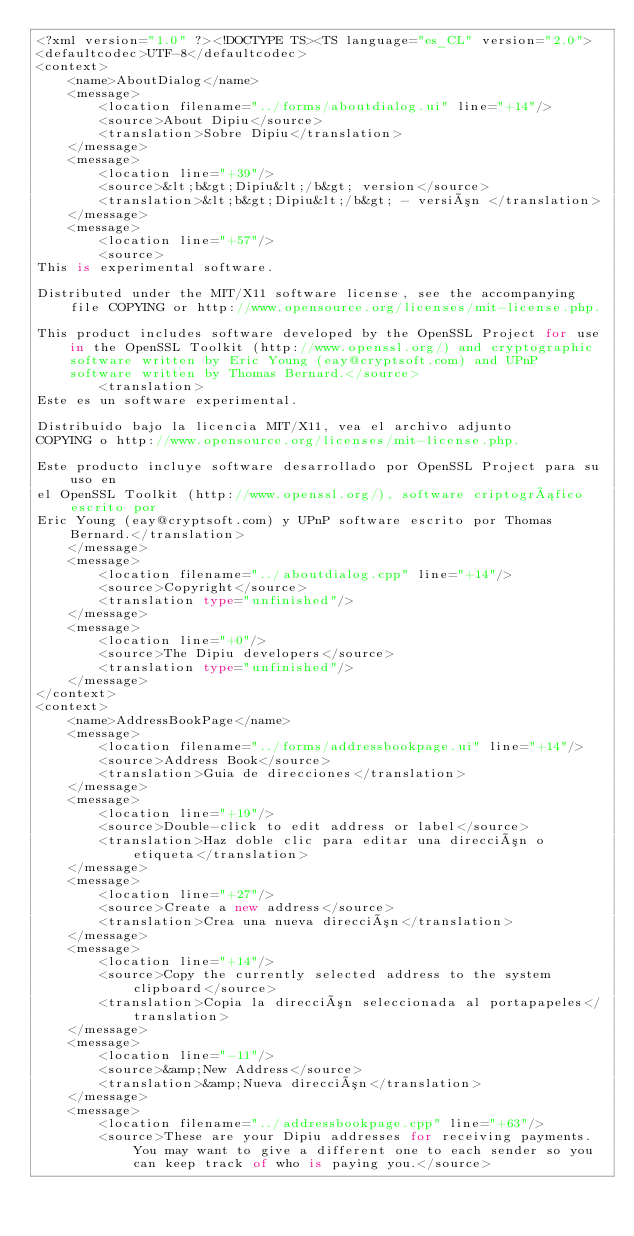Convert code to text. <code><loc_0><loc_0><loc_500><loc_500><_TypeScript_><?xml version="1.0" ?><!DOCTYPE TS><TS language="es_CL" version="2.0">
<defaultcodec>UTF-8</defaultcodec>
<context>
    <name>AboutDialog</name>
    <message>
        <location filename="../forms/aboutdialog.ui" line="+14"/>
        <source>About Dipiu</source>
        <translation>Sobre Dipiu</translation>
    </message>
    <message>
        <location line="+39"/>
        <source>&lt;b&gt;Dipiu&lt;/b&gt; version</source>
        <translation>&lt;b&gt;Dipiu&lt;/b&gt; - versión </translation>
    </message>
    <message>
        <location line="+57"/>
        <source>
This is experimental software.

Distributed under the MIT/X11 software license, see the accompanying file COPYING or http://www.opensource.org/licenses/mit-license.php.

This product includes software developed by the OpenSSL Project for use in the OpenSSL Toolkit (http://www.openssl.org/) and cryptographic software written by Eric Young (eay@cryptsoft.com) and UPnP software written by Thomas Bernard.</source>
        <translation>
Este es un software experimental.

Distribuido bajo la licencia MIT/X11, vea el archivo adjunto
COPYING o http://www.opensource.org/licenses/mit-license.php.

Este producto incluye software desarrollado por OpenSSL Project para su uso en
el OpenSSL Toolkit (http://www.openssl.org/), software criptográfico escrito por
Eric Young (eay@cryptsoft.com) y UPnP software escrito por Thomas Bernard.</translation>
    </message>
    <message>
        <location filename="../aboutdialog.cpp" line="+14"/>
        <source>Copyright</source>
        <translation type="unfinished"/>
    </message>
    <message>
        <location line="+0"/>
        <source>The Dipiu developers</source>
        <translation type="unfinished"/>
    </message>
</context>
<context>
    <name>AddressBookPage</name>
    <message>
        <location filename="../forms/addressbookpage.ui" line="+14"/>
        <source>Address Book</source>
        <translation>Guia de direcciones</translation>
    </message>
    <message>
        <location line="+19"/>
        <source>Double-click to edit address or label</source>
        <translation>Haz doble clic para editar una dirección o etiqueta</translation>
    </message>
    <message>
        <location line="+27"/>
        <source>Create a new address</source>
        <translation>Crea una nueva dirección</translation>
    </message>
    <message>
        <location line="+14"/>
        <source>Copy the currently selected address to the system clipboard</source>
        <translation>Copia la dirección seleccionada al portapapeles</translation>
    </message>
    <message>
        <location line="-11"/>
        <source>&amp;New Address</source>
        <translation>&amp;Nueva dirección</translation>
    </message>
    <message>
        <location filename="../addressbookpage.cpp" line="+63"/>
        <source>These are your Dipiu addresses for receiving payments. You may want to give a different one to each sender so you can keep track of who is paying you.</source></code> 